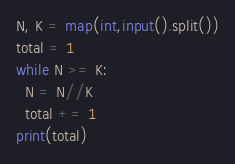<code> <loc_0><loc_0><loc_500><loc_500><_Python_>N, K = map(int,input().split())
total = 1
while N >= K:
  N = N//K
  total += 1
print(total)</code> 